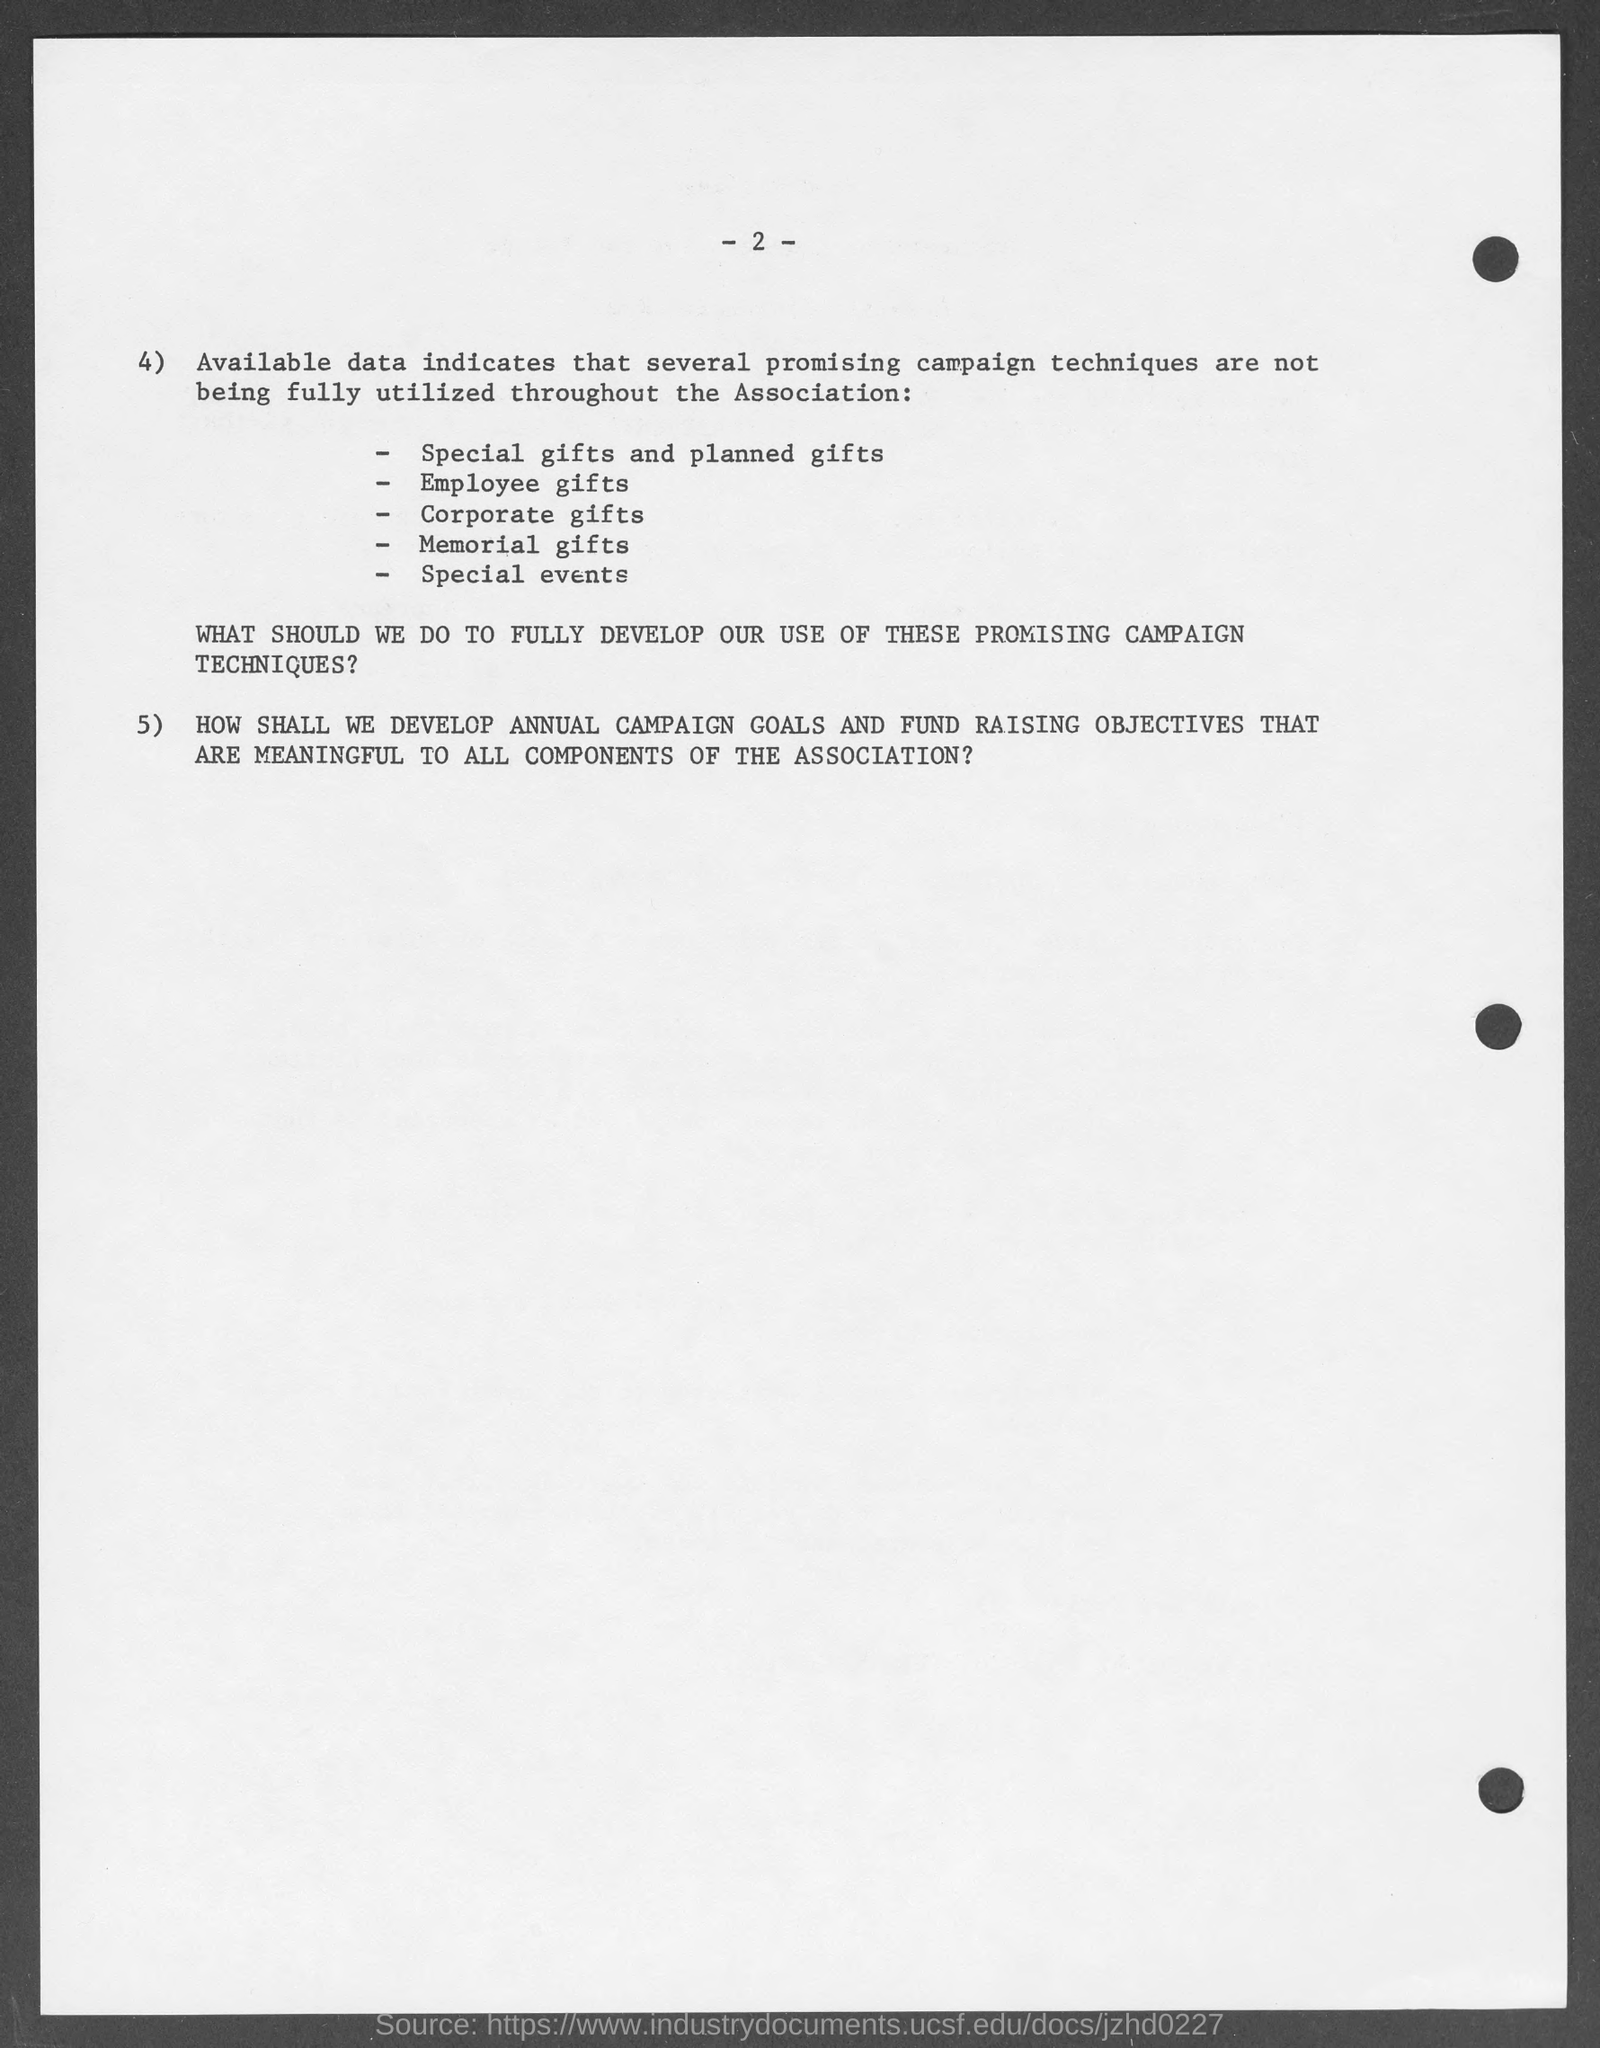What is the page no mentioned in this document?
Provide a succinct answer. 2. 